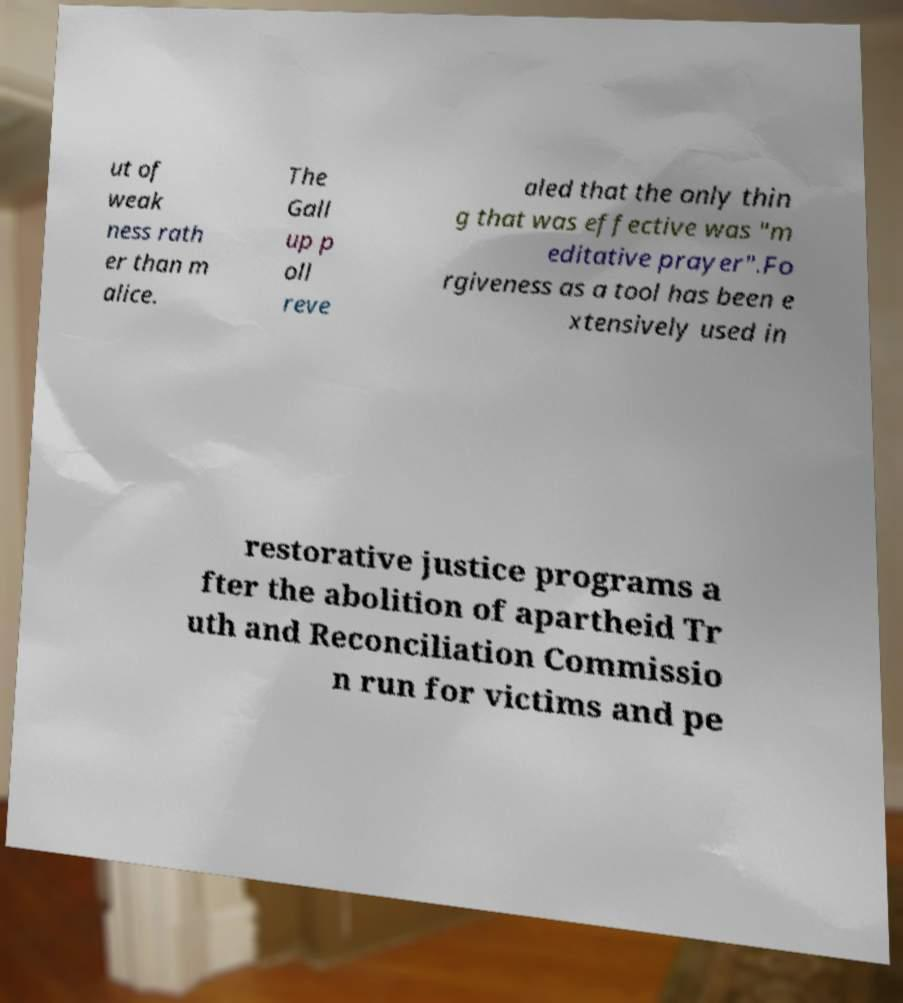Could you assist in decoding the text presented in this image and type it out clearly? ut of weak ness rath er than m alice. The Gall up p oll reve aled that the only thin g that was effective was "m editative prayer".Fo rgiveness as a tool has been e xtensively used in restorative justice programs a fter the abolition of apartheid Tr uth and Reconciliation Commissio n run for victims and pe 